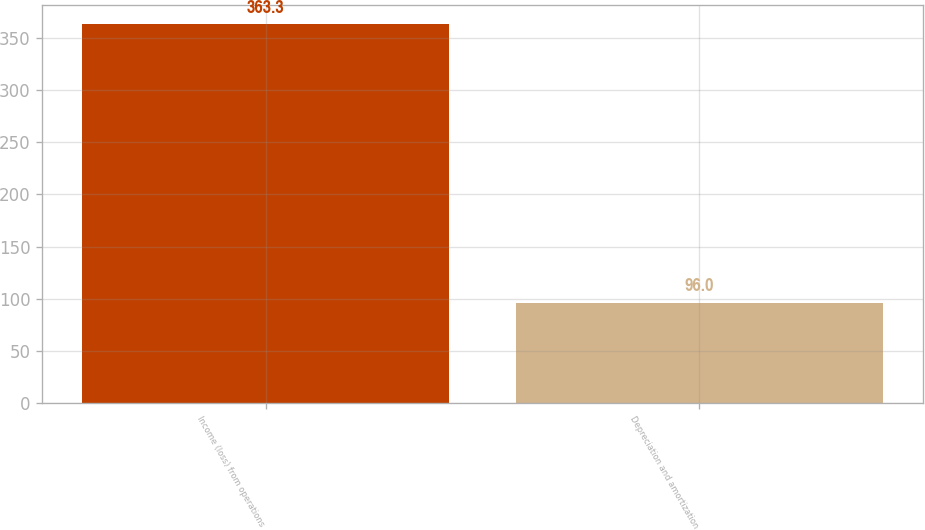<chart> <loc_0><loc_0><loc_500><loc_500><bar_chart><fcel>Income (loss) from operations<fcel>Depreciation and amortization<nl><fcel>363.3<fcel>96<nl></chart> 